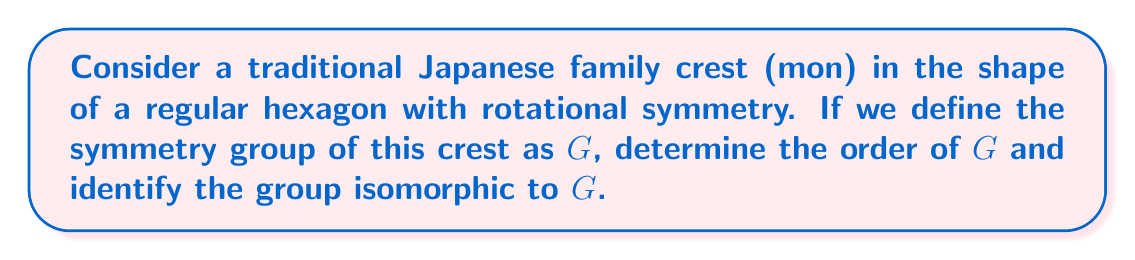Help me with this question. To analyze the symmetry group of the hexagonal Japanese family crest, we need to consider both rotational and reflectional symmetries:

1. Rotational symmetry:
   - A regular hexagon has 6-fold rotational symmetry.
   - The rotations are: 0°, 60°, 120°, 180°, 240°, 300°

2. Reflectional symmetry:
   - A regular hexagon has 6 lines of reflection (3 through opposite vertices and 3 through midpoints of opposite sides).

The symmetry group $G$ consists of all these transformations that preserve the shape of the hexagon.

To determine the order of $G$:
- Number of rotations: 6
- Number of reflections: 6
- Total number of symmetries: 6 + 6 = 12

Therefore, the order of $G$ is 12.

To identify the group isomorphic to $G$, we need to recognize that this symmetry group is known as the dihedral group of order 12, denoted as $D_6$ or $D_{12}$ (depending on the notation system).

The dihedral group $D_6$ is defined as:

$$ D_6 = \langle r, s \mid r^6 = s^2 = 1, srs = r^{-1} \rangle $$

Where $r$ represents a rotation of 60° and $s$ represents a reflection.

This group structure perfectly captures the symmetries of the hexagonal family crest, as it includes all possible rotations and reflections that preserve the shape.
Answer: The order of the symmetry group $G$ is 12, and $G$ is isomorphic to the dihedral group $D_6$ (or $D_{12}$). 